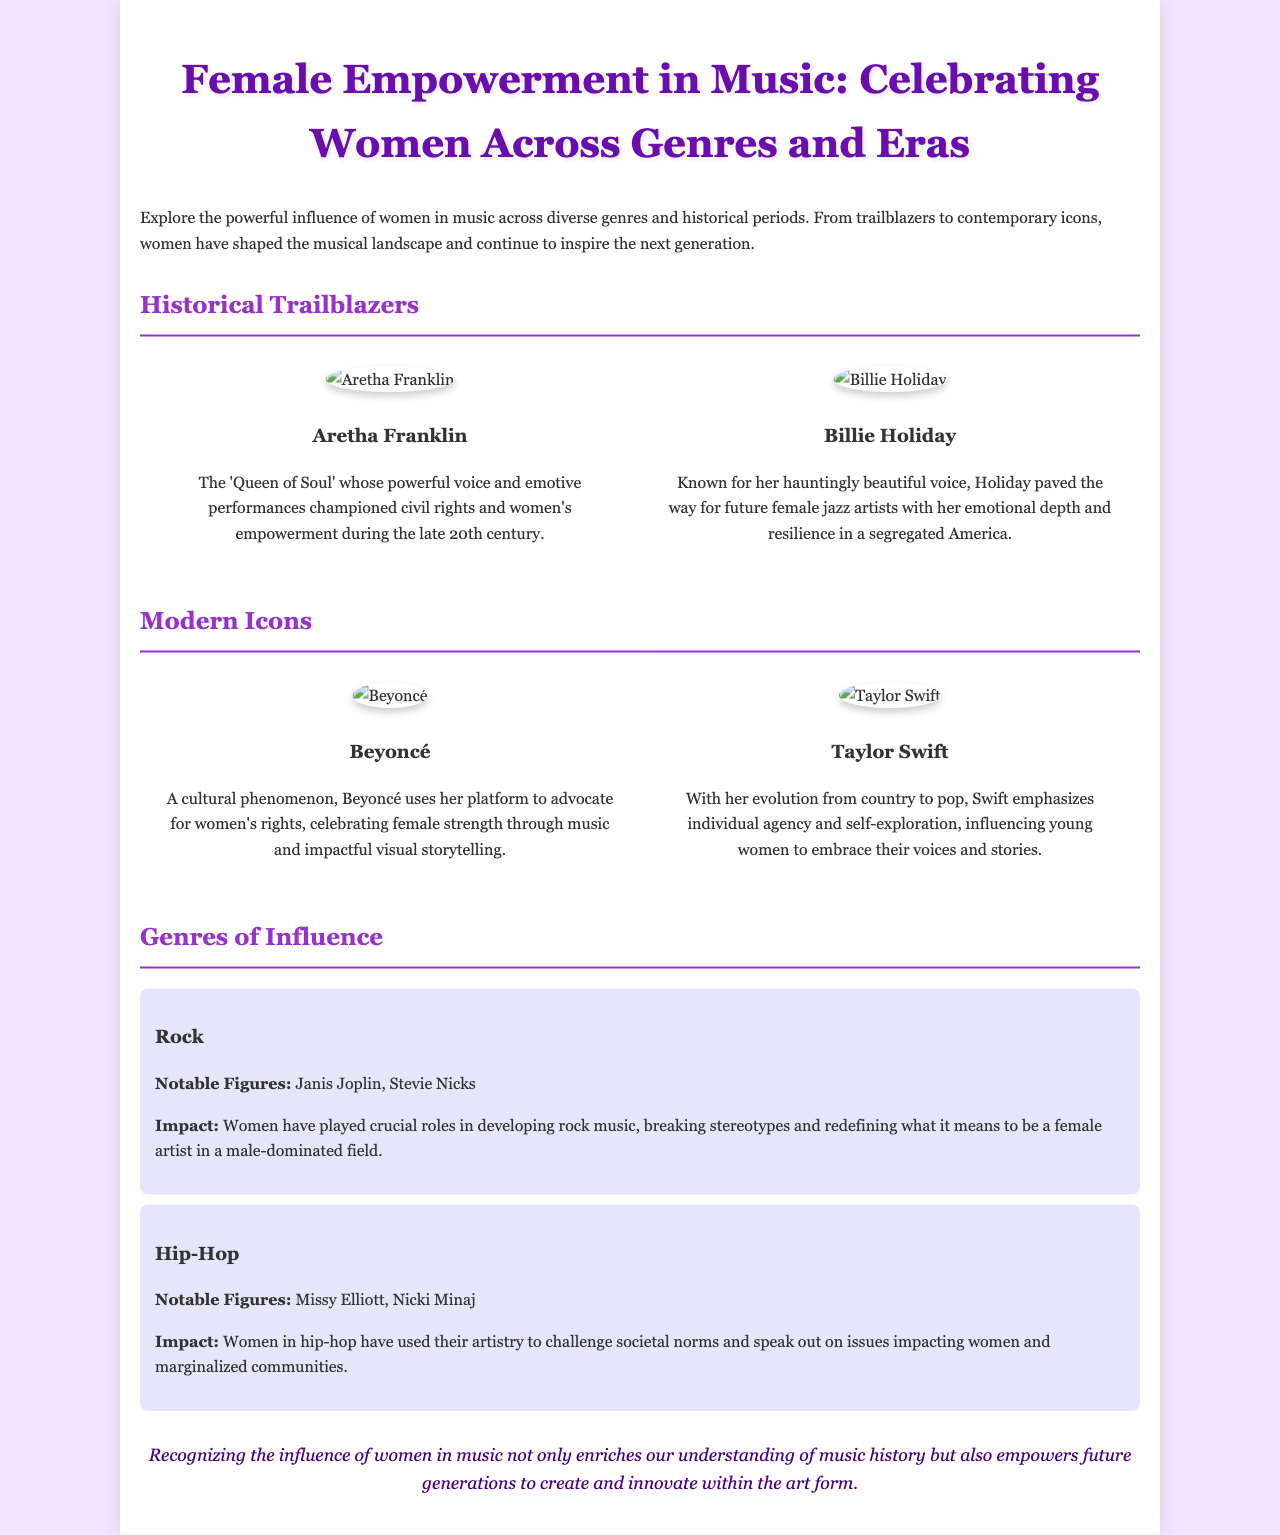what is the title of the brochure? The title of the brochure is prominently displayed at the top of the document.
Answer: Female Empowerment in Music: Celebrating Women Across Genres and Eras who is referred to as the 'Queen of Soul'? This title is given to Aretha Franklin in the brochure.
Answer: Aretha Franklin which two genres are specifically highlighted in the genres of influence section? The document lists two specific genres along with notable figures in each genre.
Answer: Rock and Hip-Hop who are two notable figures in Hip-Hop mentioned in the document? The brochure provides names as examples of women influential in Hip-Hop music.
Answer: Missy Elliott and Nicki Minaj what is one impact of women in rock music according to the brochure? The impact described refers to the way women have influenced the development of rock music.
Answer: Breaking stereotypes why does the document celebrate women in music? The rationale for the celebration of women in music encompasses their influence and empowerment.
Answer: To empower future generations which contemporary artist is known for advocating for women's rights? The brochure lists a modern icon who uses her platform for advocacy.
Answer: Beyoncé what historical figure is known for paving the way for female jazz artists? The document names a prominent figure in jazz music who had significant influence.
Answer: Billie Holiday 